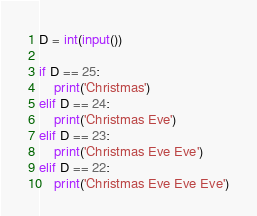Convert code to text. <code><loc_0><loc_0><loc_500><loc_500><_Python_>D = int(input())

if D == 25:
    print('Christmas')
elif D == 24:
    print('Christmas Eve')
elif D == 23:
    print('Christmas Eve Eve')
elif D == 22:
    print('Christmas Eve Eve Eve')
</code> 